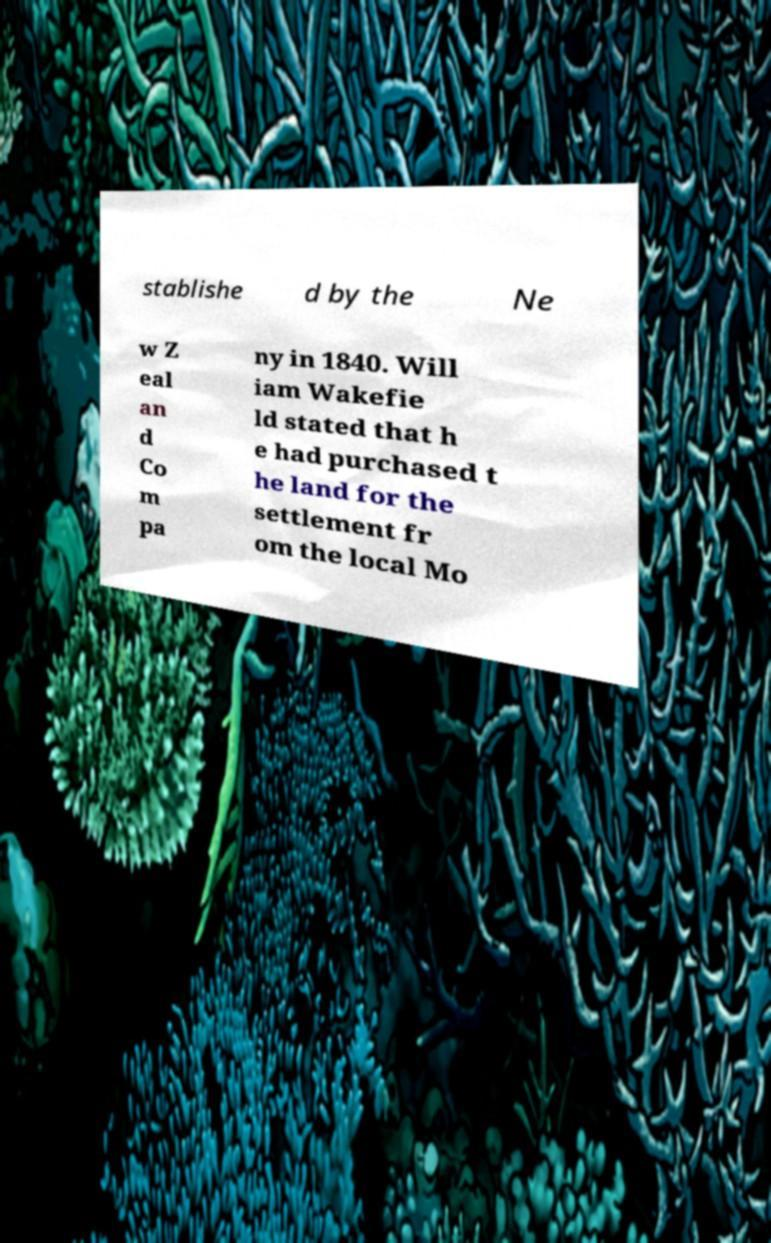What messages or text are displayed in this image? I need them in a readable, typed format. stablishe d by the Ne w Z eal an d Co m pa ny in 1840. Will iam Wakefie ld stated that h e had purchased t he land for the settlement fr om the local Mo 